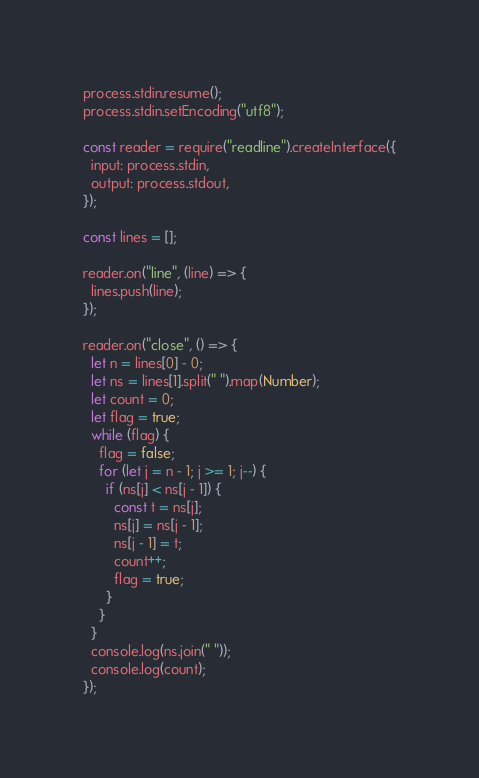<code> <loc_0><loc_0><loc_500><loc_500><_JavaScript_>process.stdin.resume();
process.stdin.setEncoding("utf8");

const reader = require("readline").createInterface({
  input: process.stdin,
  output: process.stdout,
});

const lines = [];

reader.on("line", (line) => {
  lines.push(line);
});

reader.on("close", () => {
  let n = lines[0] - 0;
  let ns = lines[1].split(" ").map(Number);
  let count = 0;
  let flag = true;
  while (flag) {
    flag = false;
    for (let j = n - 1; j >= 1; j--) {
      if (ns[j] < ns[j - 1]) {
        const t = ns[j];
        ns[j] = ns[j - 1];
        ns[j - 1] = t;
        count++;
        flag = true;
      }
    }
  }
  console.log(ns.join(" "));
  console.log(count);
});

</code> 